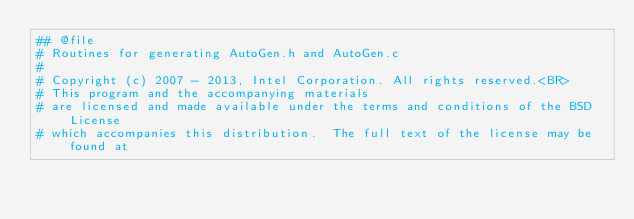Convert code to text. <code><loc_0><loc_0><loc_500><loc_500><_Python_>## @file
# Routines for generating AutoGen.h and AutoGen.c
#
# Copyright (c) 2007 - 2013, Intel Corporation. All rights reserved.<BR>
# This program and the accompanying materials
# are licensed and made available under the terms and conditions of the BSD License
# which accompanies this distribution.  The full text of the license may be found at</code> 